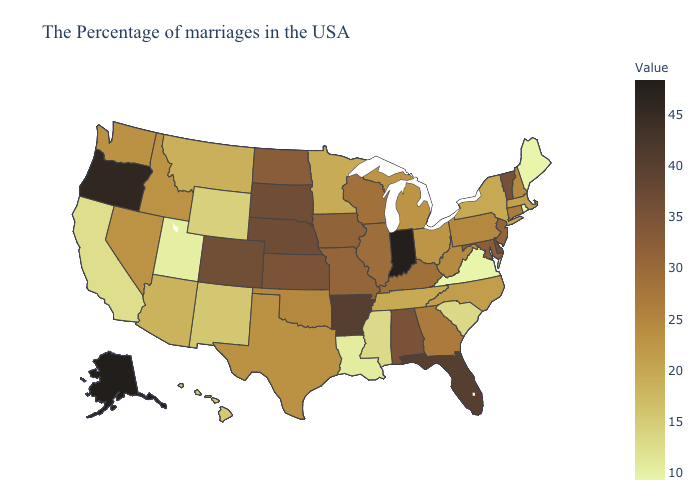Does Maine have the lowest value in the USA?
Short answer required. Yes. Does Maine have the lowest value in the USA?
Answer briefly. Yes. Which states have the highest value in the USA?
Quick response, please. Alaska. Does Rhode Island have the lowest value in the USA?
Answer briefly. Yes. Does the map have missing data?
Keep it brief. No. 